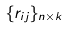Convert formula to latex. <formula><loc_0><loc_0><loc_500><loc_500>\{ r _ { i j } \} _ { n \times k }</formula> 